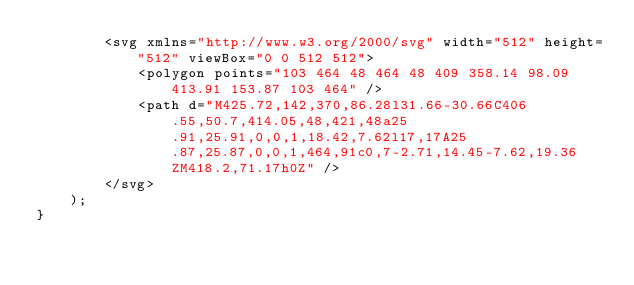Convert code to text. <code><loc_0><loc_0><loc_500><loc_500><_JavaScript_>		<svg xmlns="http://www.w3.org/2000/svg" width="512" height="512" viewBox="0 0 512 512">
			<polygon points="103 464 48 464 48 409 358.14 98.09 413.91 153.87 103 464" />
			<path d="M425.72,142,370,86.28l31.66-30.66C406.55,50.7,414.05,48,421,48a25.91,25.91,0,0,1,18.42,7.62l17,17A25.87,25.87,0,0,1,464,91c0,7-2.71,14.45-7.62,19.36ZM418.2,71.17h0Z" />
		</svg>
	);
}
</code> 